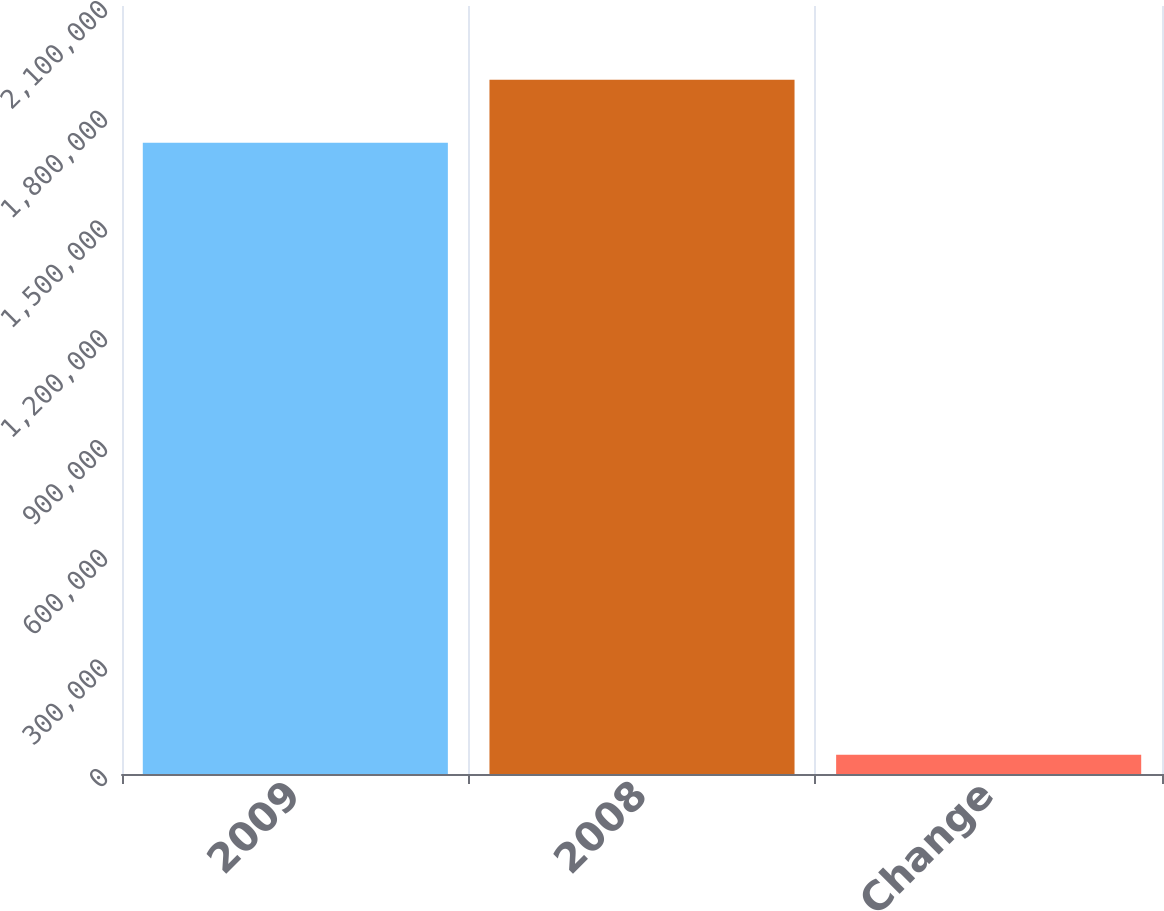Convert chart to OTSL. <chart><loc_0><loc_0><loc_500><loc_500><bar_chart><fcel>2009<fcel>2008<fcel>Change<nl><fcel>1.72577e+06<fcel>1.89835e+06<fcel>52409<nl></chart> 